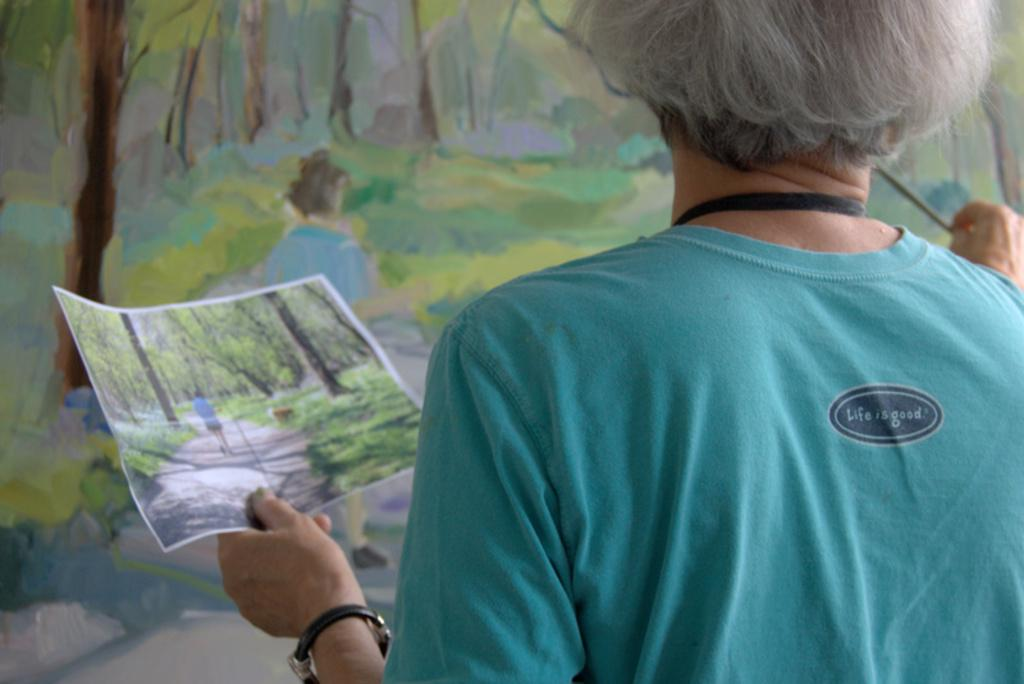Who is present in the image? There is a person in the image. What is the person wearing? The person is wearing a blue t-shirt. What is the person holding in their hand? The person is holding a paper in their hand. What can be seen in the background of the image? There is a painting in the background of the image. Where is the playground located in the image? There is no playground present in the image. What type of stocking is the person wearing in the image? The person is not wearing any stockings in the image. 